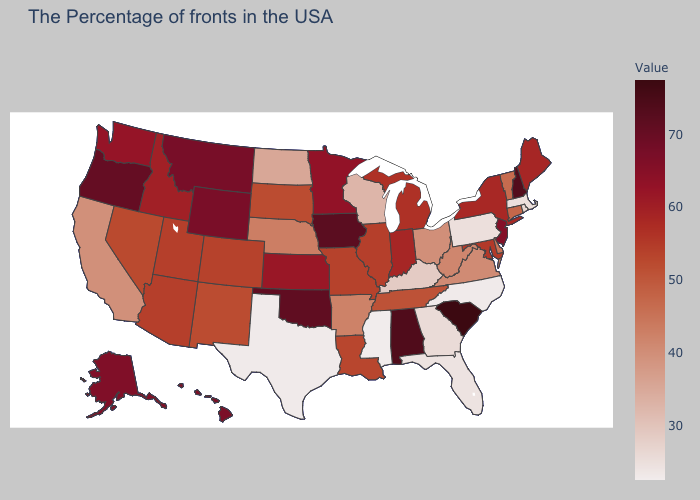Does the map have missing data?
Concise answer only. No. Which states hav the highest value in the Northeast?
Answer briefly. New Hampshire. Which states have the highest value in the USA?
Quick response, please. South Carolina. Does Arkansas have the highest value in the USA?
Quick response, please. No. 